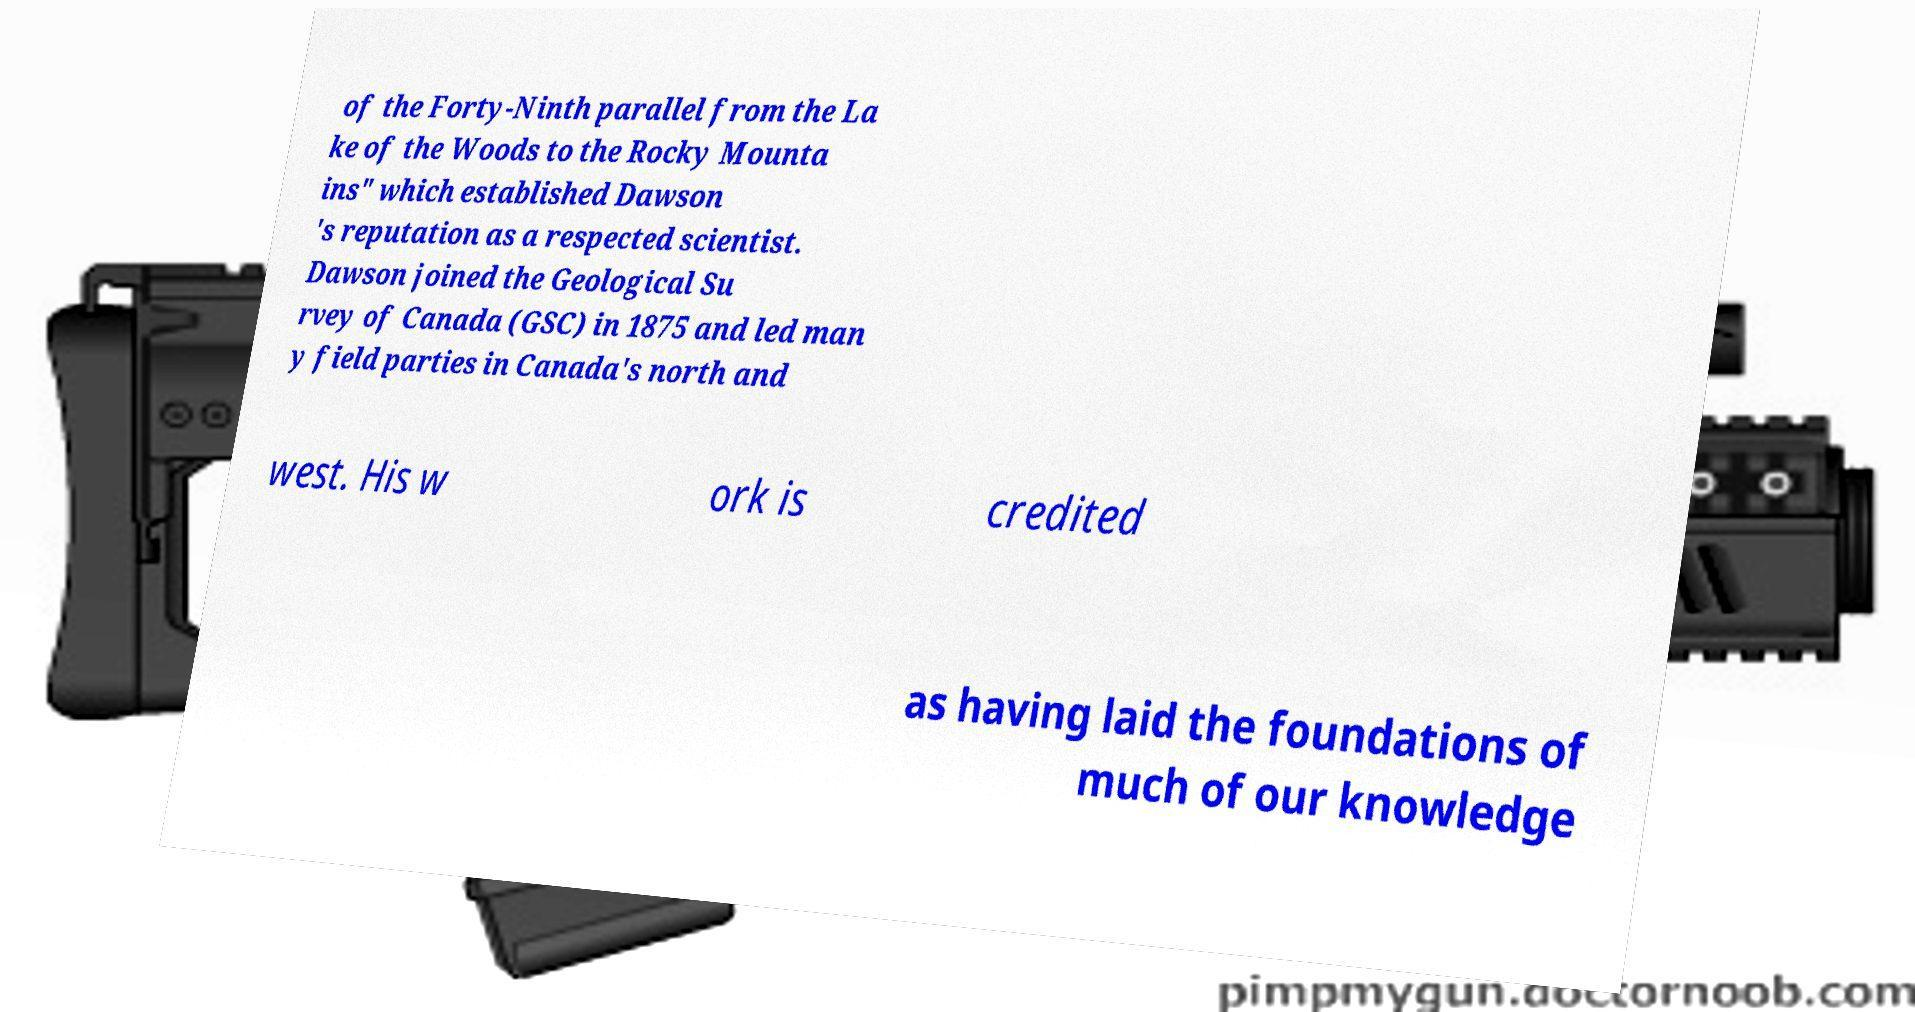Please read and relay the text visible in this image. What does it say? of the Forty-Ninth parallel from the La ke of the Woods to the Rocky Mounta ins" which established Dawson 's reputation as a respected scientist. Dawson joined the Geological Su rvey of Canada (GSC) in 1875 and led man y field parties in Canada's north and west. His w ork is credited as having laid the foundations of much of our knowledge 